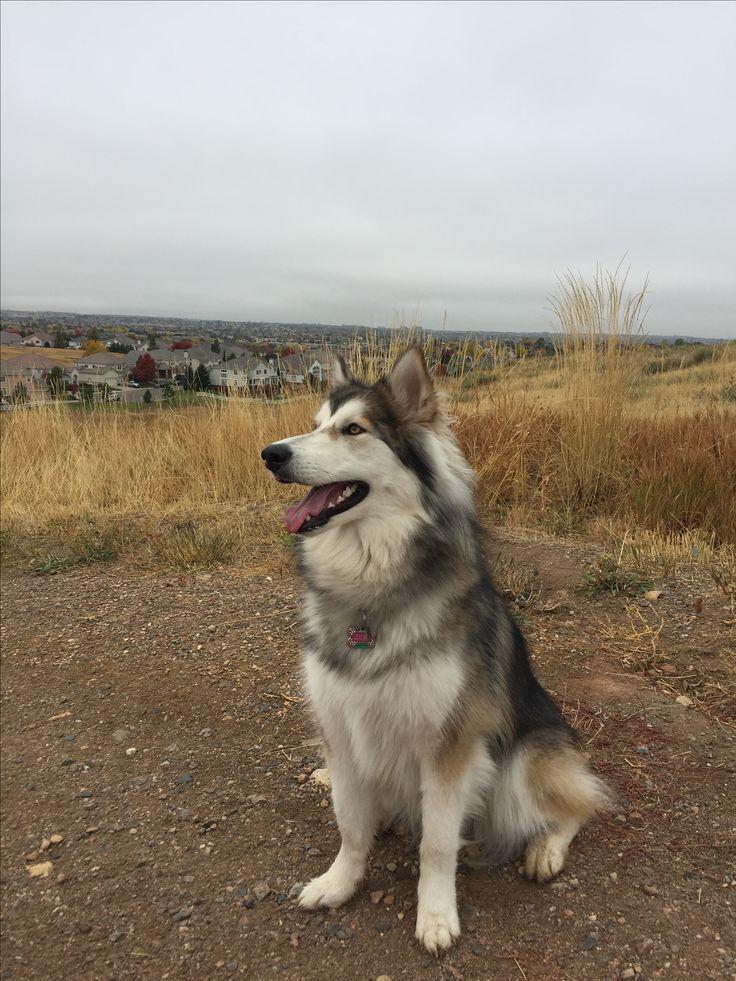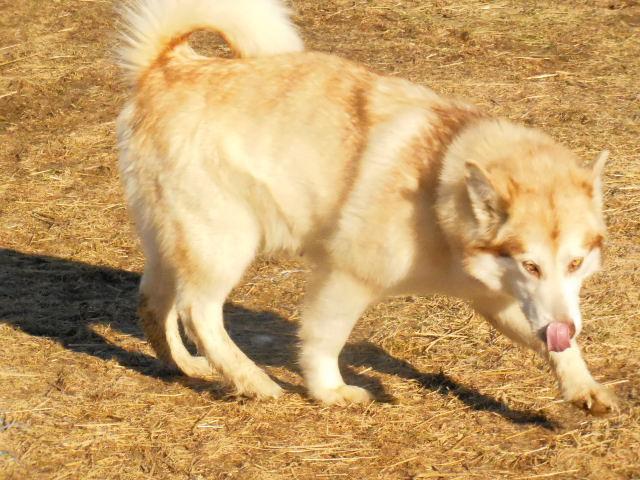The first image is the image on the left, the second image is the image on the right. Given the left and right images, does the statement "The left and right image contains the same number of dogs with one sitting and the other standing outside." hold true? Answer yes or no. Yes. The first image is the image on the left, the second image is the image on the right. Evaluate the accuracy of this statement regarding the images: "Each dog has an open mouth and one dog is wearing a harness.". Is it true? Answer yes or no. No. 